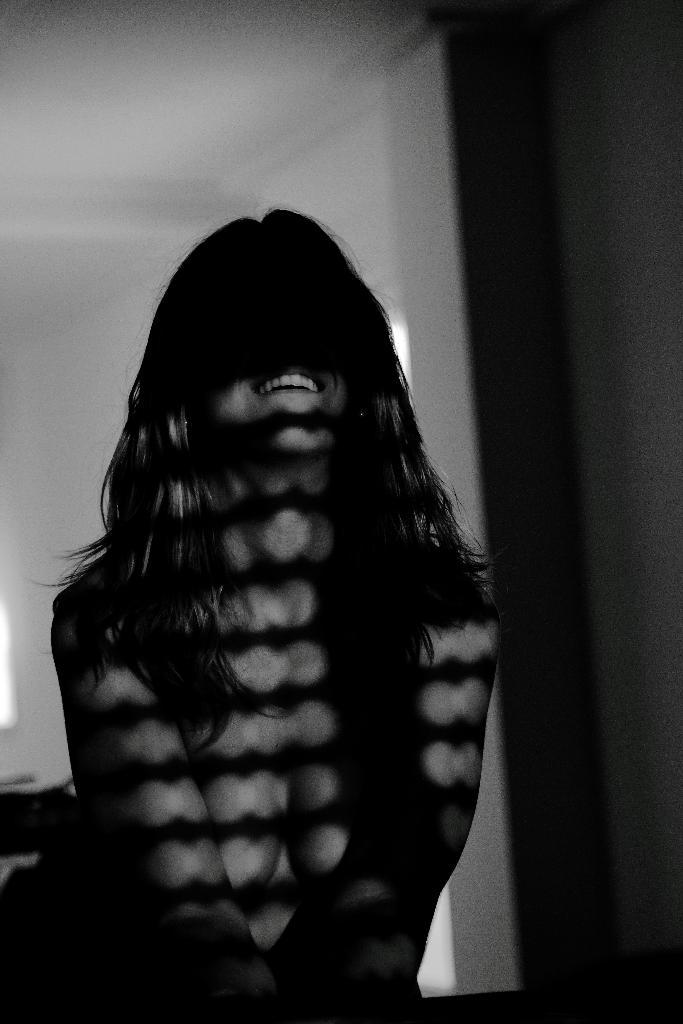Who is present in the image? There is a woman in the image. What is the woman's facial expression? The woman is smiling. What can be seen in the background of the image? There is a wall and a window in the background of the image. Can you hear the woman singing in the image? There is no sound or indication of singing in the image, so it cannot be determined whether the woman is singing or not. 